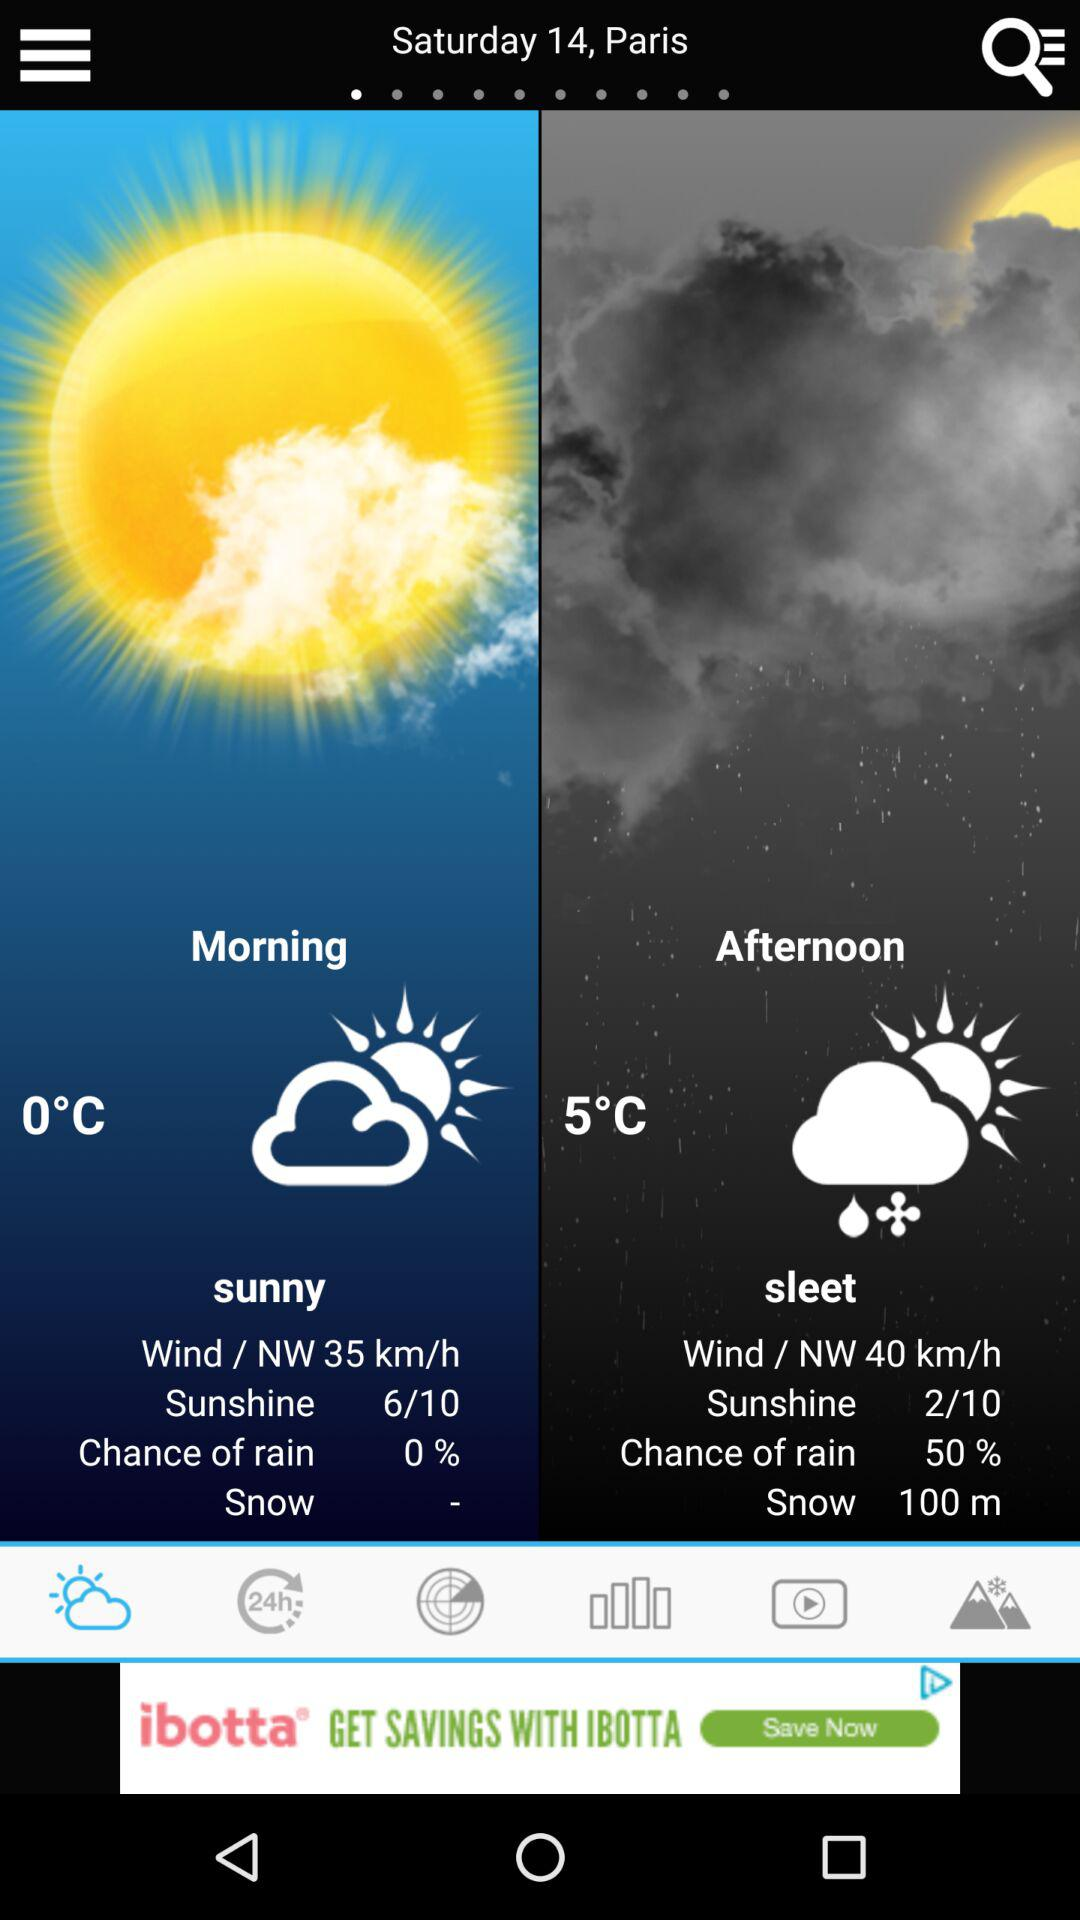How is the weather in the morning? The weather is sunny in the morning. 